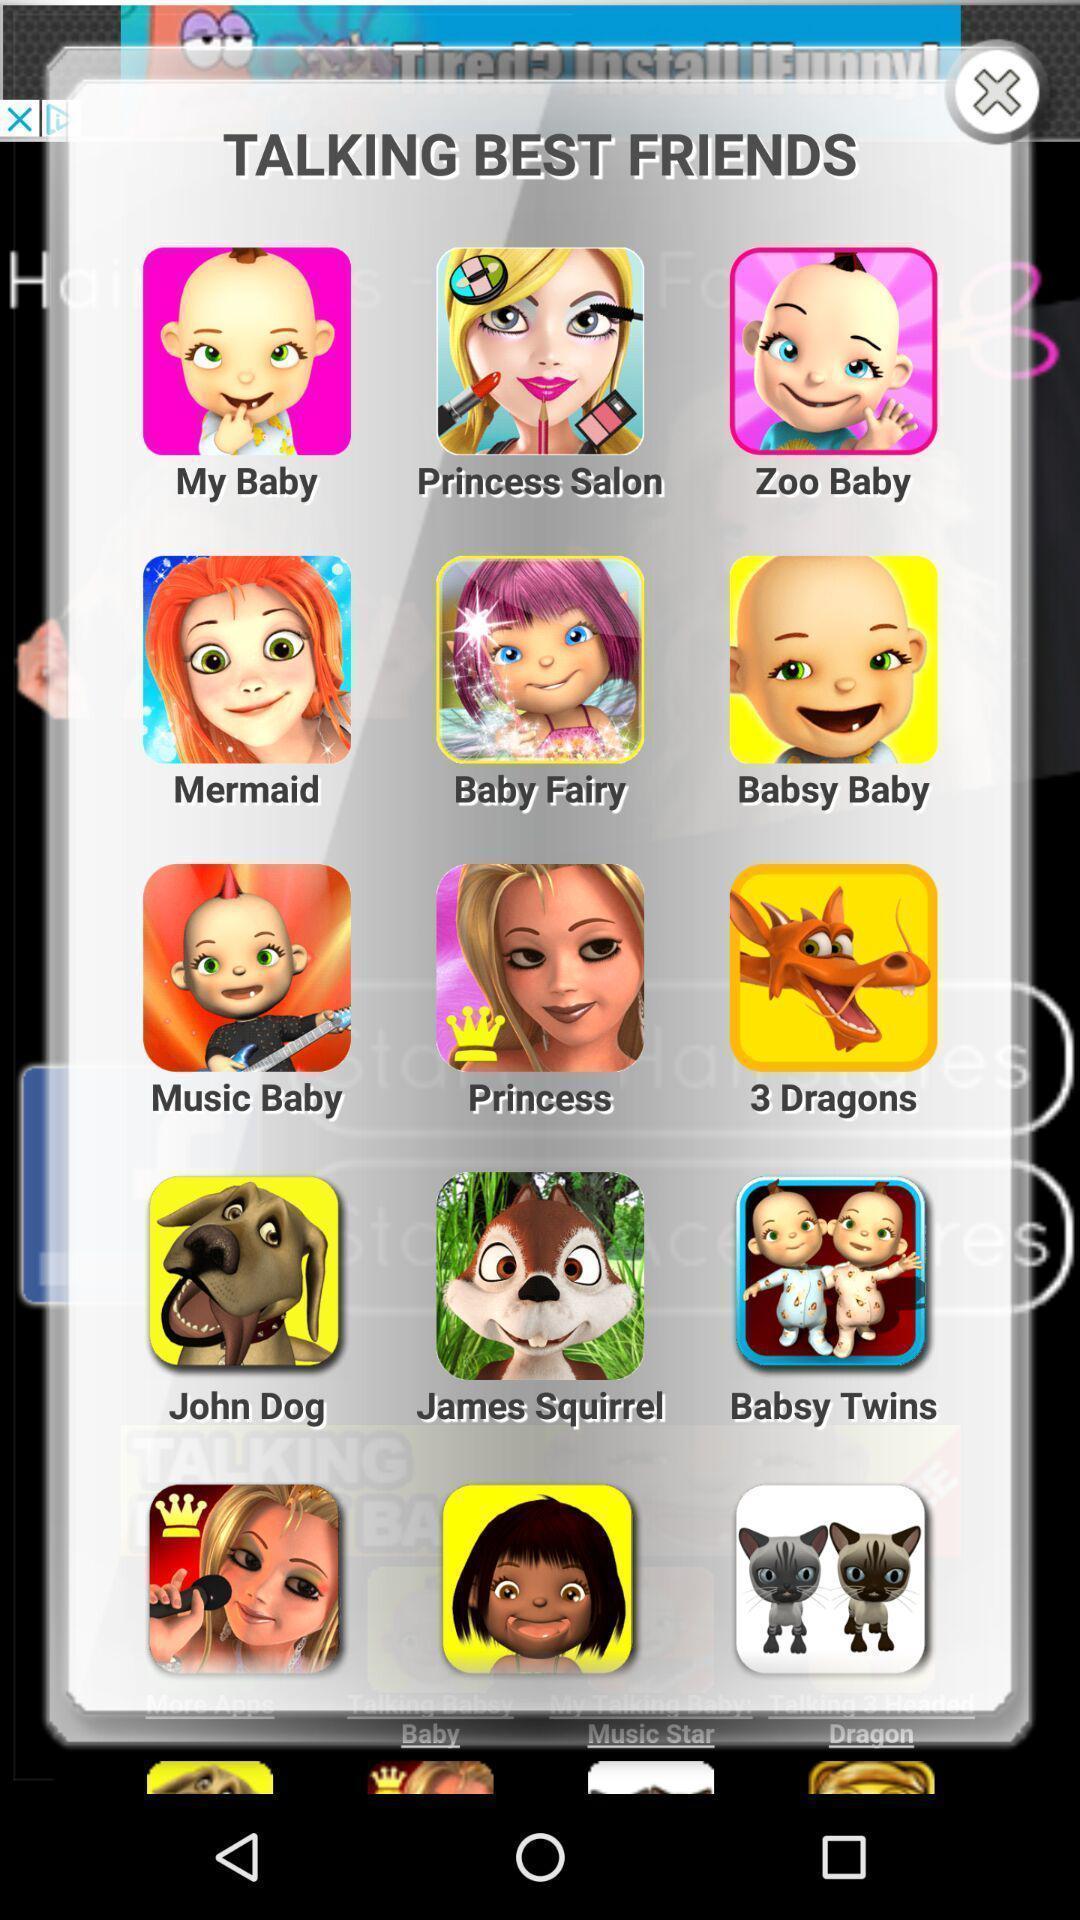Summarize the main components in this picture. Popup with list of options in the gaming app. 